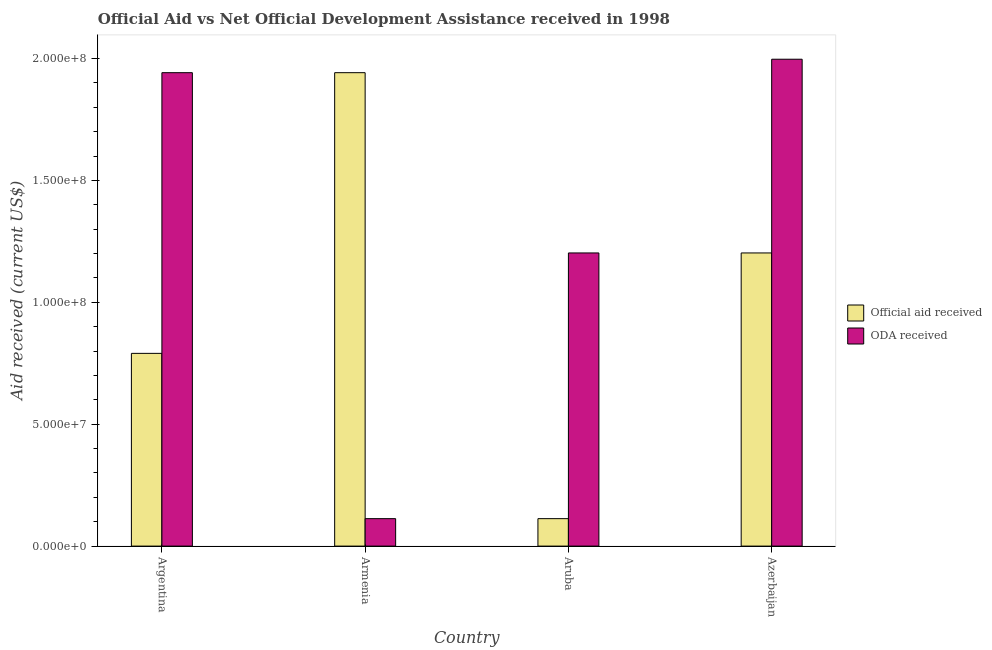Are the number of bars per tick equal to the number of legend labels?
Give a very brief answer. Yes. What is the label of the 4th group of bars from the left?
Offer a very short reply. Azerbaijan. In how many cases, is the number of bars for a given country not equal to the number of legend labels?
Provide a short and direct response. 0. What is the official aid received in Argentina?
Your response must be concise. 7.91e+07. Across all countries, what is the maximum oda received?
Give a very brief answer. 2.00e+08. Across all countries, what is the minimum oda received?
Provide a succinct answer. 1.13e+07. In which country was the oda received maximum?
Give a very brief answer. Azerbaijan. In which country was the official aid received minimum?
Keep it short and to the point. Aruba. What is the total oda received in the graph?
Your answer should be compact. 5.25e+08. What is the difference between the oda received in Armenia and that in Azerbaijan?
Give a very brief answer. -1.88e+08. What is the difference between the oda received in Azerbaijan and the official aid received in Armenia?
Your response must be concise. 5.52e+06. What is the average official aid received per country?
Keep it short and to the point. 1.01e+08. What is the difference between the official aid received and oda received in Aruba?
Provide a succinct answer. -1.09e+08. In how many countries, is the oda received greater than 50000000 US$?
Ensure brevity in your answer.  3. What is the ratio of the oda received in Aruba to that in Azerbaijan?
Provide a succinct answer. 0.6. Is the oda received in Aruba less than that in Azerbaijan?
Your answer should be very brief. Yes. What is the difference between the highest and the second highest official aid received?
Give a very brief answer. 7.40e+07. What is the difference between the highest and the lowest official aid received?
Keep it short and to the point. 1.83e+08. In how many countries, is the official aid received greater than the average official aid received taken over all countries?
Keep it short and to the point. 2. What does the 1st bar from the left in Azerbaijan represents?
Give a very brief answer. Official aid received. What does the 2nd bar from the right in Azerbaijan represents?
Your response must be concise. Official aid received. How many bars are there?
Your response must be concise. 8. How many countries are there in the graph?
Make the answer very short. 4. What is the difference between two consecutive major ticks on the Y-axis?
Your answer should be very brief. 5.00e+07. Does the graph contain grids?
Offer a terse response. No. Where does the legend appear in the graph?
Offer a terse response. Center right. How are the legend labels stacked?
Offer a terse response. Vertical. What is the title of the graph?
Make the answer very short. Official Aid vs Net Official Development Assistance received in 1998 . Does "Adolescent fertility rate" appear as one of the legend labels in the graph?
Give a very brief answer. No. What is the label or title of the Y-axis?
Your answer should be very brief. Aid received (current US$). What is the Aid received (current US$) of Official aid received in Argentina?
Your response must be concise. 7.91e+07. What is the Aid received (current US$) in ODA received in Argentina?
Offer a very short reply. 1.94e+08. What is the Aid received (current US$) of Official aid received in Armenia?
Make the answer very short. 1.94e+08. What is the Aid received (current US$) of ODA received in Armenia?
Your answer should be very brief. 1.13e+07. What is the Aid received (current US$) in Official aid received in Aruba?
Make the answer very short. 1.13e+07. What is the Aid received (current US$) of ODA received in Aruba?
Offer a very short reply. 1.20e+08. What is the Aid received (current US$) in Official aid received in Azerbaijan?
Give a very brief answer. 1.20e+08. What is the Aid received (current US$) of ODA received in Azerbaijan?
Your response must be concise. 2.00e+08. Across all countries, what is the maximum Aid received (current US$) of Official aid received?
Your response must be concise. 1.94e+08. Across all countries, what is the maximum Aid received (current US$) in ODA received?
Give a very brief answer. 2.00e+08. Across all countries, what is the minimum Aid received (current US$) in Official aid received?
Provide a succinct answer. 1.13e+07. Across all countries, what is the minimum Aid received (current US$) in ODA received?
Offer a very short reply. 1.13e+07. What is the total Aid received (current US$) of Official aid received in the graph?
Offer a very short reply. 4.05e+08. What is the total Aid received (current US$) of ODA received in the graph?
Ensure brevity in your answer.  5.25e+08. What is the difference between the Aid received (current US$) in Official aid received in Argentina and that in Armenia?
Make the answer very short. -1.15e+08. What is the difference between the Aid received (current US$) in ODA received in Argentina and that in Armenia?
Your answer should be very brief. 1.83e+08. What is the difference between the Aid received (current US$) of Official aid received in Argentina and that in Aruba?
Make the answer very short. 6.78e+07. What is the difference between the Aid received (current US$) of ODA received in Argentina and that in Aruba?
Give a very brief answer. 7.40e+07. What is the difference between the Aid received (current US$) in Official aid received in Argentina and that in Azerbaijan?
Offer a terse response. -4.12e+07. What is the difference between the Aid received (current US$) in ODA received in Argentina and that in Azerbaijan?
Offer a terse response. -5.52e+06. What is the difference between the Aid received (current US$) in Official aid received in Armenia and that in Aruba?
Offer a very short reply. 1.83e+08. What is the difference between the Aid received (current US$) in ODA received in Armenia and that in Aruba?
Provide a short and direct response. -1.09e+08. What is the difference between the Aid received (current US$) in Official aid received in Armenia and that in Azerbaijan?
Offer a very short reply. 7.40e+07. What is the difference between the Aid received (current US$) in ODA received in Armenia and that in Azerbaijan?
Ensure brevity in your answer.  -1.88e+08. What is the difference between the Aid received (current US$) of Official aid received in Aruba and that in Azerbaijan?
Your answer should be very brief. -1.09e+08. What is the difference between the Aid received (current US$) of ODA received in Aruba and that in Azerbaijan?
Offer a terse response. -7.95e+07. What is the difference between the Aid received (current US$) in Official aid received in Argentina and the Aid received (current US$) in ODA received in Armenia?
Give a very brief answer. 6.78e+07. What is the difference between the Aid received (current US$) of Official aid received in Argentina and the Aid received (current US$) of ODA received in Aruba?
Make the answer very short. -4.12e+07. What is the difference between the Aid received (current US$) in Official aid received in Argentina and the Aid received (current US$) in ODA received in Azerbaijan?
Give a very brief answer. -1.21e+08. What is the difference between the Aid received (current US$) in Official aid received in Armenia and the Aid received (current US$) in ODA received in Aruba?
Offer a very short reply. 7.40e+07. What is the difference between the Aid received (current US$) in Official aid received in Armenia and the Aid received (current US$) in ODA received in Azerbaijan?
Offer a terse response. -5.52e+06. What is the difference between the Aid received (current US$) in Official aid received in Aruba and the Aid received (current US$) in ODA received in Azerbaijan?
Your answer should be very brief. -1.88e+08. What is the average Aid received (current US$) in Official aid received per country?
Keep it short and to the point. 1.01e+08. What is the average Aid received (current US$) in ODA received per country?
Your answer should be compact. 1.31e+08. What is the difference between the Aid received (current US$) in Official aid received and Aid received (current US$) in ODA received in Argentina?
Give a very brief answer. -1.15e+08. What is the difference between the Aid received (current US$) in Official aid received and Aid received (current US$) in ODA received in Armenia?
Provide a short and direct response. 1.83e+08. What is the difference between the Aid received (current US$) of Official aid received and Aid received (current US$) of ODA received in Aruba?
Provide a succinct answer. -1.09e+08. What is the difference between the Aid received (current US$) in Official aid received and Aid received (current US$) in ODA received in Azerbaijan?
Ensure brevity in your answer.  -7.95e+07. What is the ratio of the Aid received (current US$) in Official aid received in Argentina to that in Armenia?
Ensure brevity in your answer.  0.41. What is the ratio of the Aid received (current US$) in ODA received in Argentina to that in Armenia?
Make the answer very short. 17.25. What is the ratio of the Aid received (current US$) of Official aid received in Argentina to that in Aruba?
Your answer should be compact. 7.02. What is the ratio of the Aid received (current US$) of ODA received in Argentina to that in Aruba?
Your response must be concise. 1.61. What is the ratio of the Aid received (current US$) in Official aid received in Argentina to that in Azerbaijan?
Provide a short and direct response. 0.66. What is the ratio of the Aid received (current US$) in ODA received in Argentina to that in Azerbaijan?
Your answer should be very brief. 0.97. What is the ratio of the Aid received (current US$) of Official aid received in Armenia to that in Aruba?
Give a very brief answer. 17.25. What is the ratio of the Aid received (current US$) in ODA received in Armenia to that in Aruba?
Give a very brief answer. 0.09. What is the ratio of the Aid received (current US$) of Official aid received in Armenia to that in Azerbaijan?
Offer a terse response. 1.61. What is the ratio of the Aid received (current US$) of ODA received in Armenia to that in Azerbaijan?
Offer a very short reply. 0.06. What is the ratio of the Aid received (current US$) of Official aid received in Aruba to that in Azerbaijan?
Offer a terse response. 0.09. What is the ratio of the Aid received (current US$) of ODA received in Aruba to that in Azerbaijan?
Provide a succinct answer. 0.6. What is the difference between the highest and the second highest Aid received (current US$) of Official aid received?
Offer a terse response. 7.40e+07. What is the difference between the highest and the second highest Aid received (current US$) of ODA received?
Provide a succinct answer. 5.52e+06. What is the difference between the highest and the lowest Aid received (current US$) in Official aid received?
Your answer should be compact. 1.83e+08. What is the difference between the highest and the lowest Aid received (current US$) in ODA received?
Provide a short and direct response. 1.88e+08. 